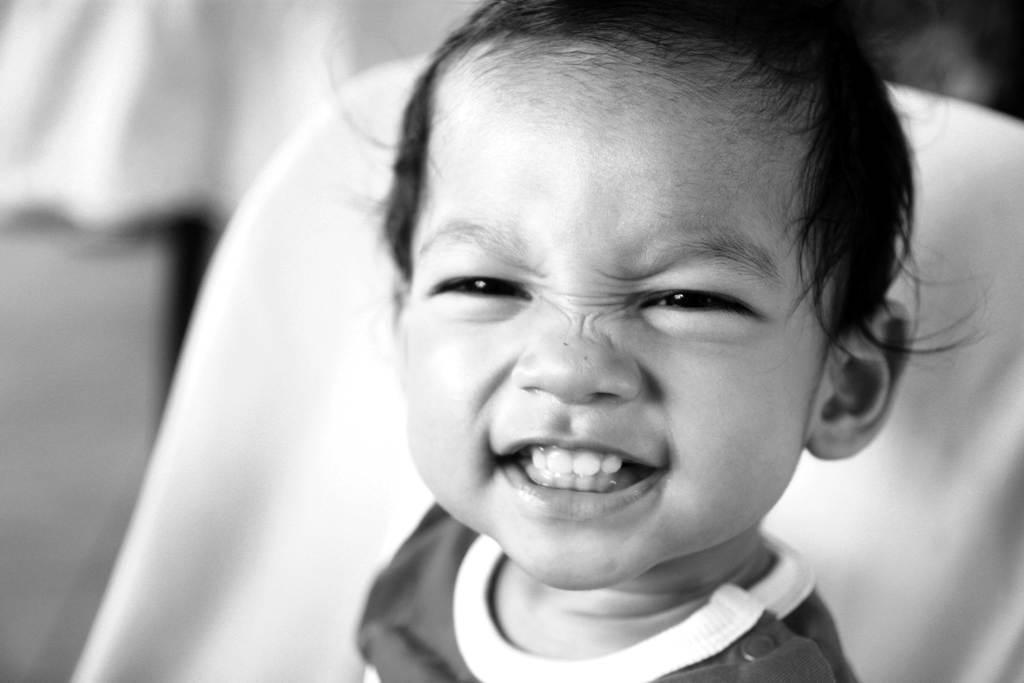Describe this image in one or two sentences. This picture is in black and white where we can see a child sitting on the chair. The background of the image is blurred. 